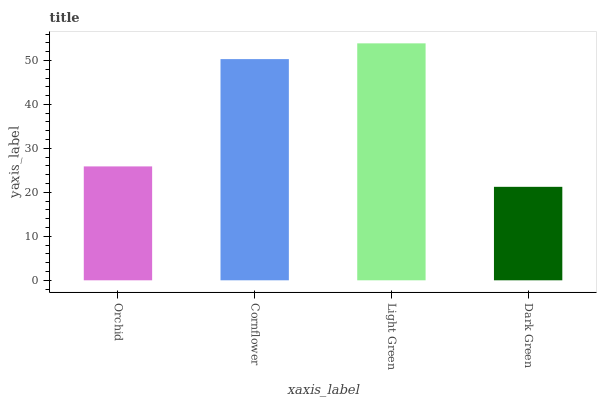Is Dark Green the minimum?
Answer yes or no. Yes. Is Light Green the maximum?
Answer yes or no. Yes. Is Cornflower the minimum?
Answer yes or no. No. Is Cornflower the maximum?
Answer yes or no. No. Is Cornflower greater than Orchid?
Answer yes or no. Yes. Is Orchid less than Cornflower?
Answer yes or no. Yes. Is Orchid greater than Cornflower?
Answer yes or no. No. Is Cornflower less than Orchid?
Answer yes or no. No. Is Cornflower the high median?
Answer yes or no. Yes. Is Orchid the low median?
Answer yes or no. Yes. Is Light Green the high median?
Answer yes or no. No. Is Cornflower the low median?
Answer yes or no. No. 